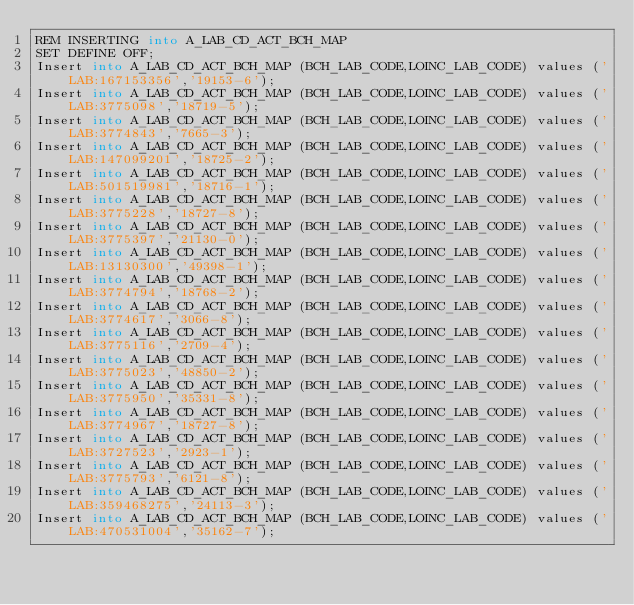Convert code to text. <code><loc_0><loc_0><loc_500><loc_500><_SQL_>REM INSERTING into A_LAB_CD_ACT_BCH_MAP
SET DEFINE OFF;
Insert into A_LAB_CD_ACT_BCH_MAP (BCH_LAB_CODE,LOINC_LAB_CODE) values ('LAB:167153356','19153-6');
Insert into A_LAB_CD_ACT_BCH_MAP (BCH_LAB_CODE,LOINC_LAB_CODE) values ('LAB:3775098','18719-5');
Insert into A_LAB_CD_ACT_BCH_MAP (BCH_LAB_CODE,LOINC_LAB_CODE) values ('LAB:3774843','7665-3');
Insert into A_LAB_CD_ACT_BCH_MAP (BCH_LAB_CODE,LOINC_LAB_CODE) values ('LAB:147099201','18725-2');
Insert into A_LAB_CD_ACT_BCH_MAP (BCH_LAB_CODE,LOINC_LAB_CODE) values ('LAB:501519981','18716-1');
Insert into A_LAB_CD_ACT_BCH_MAP (BCH_LAB_CODE,LOINC_LAB_CODE) values ('LAB:3775228','18727-8');
Insert into A_LAB_CD_ACT_BCH_MAP (BCH_LAB_CODE,LOINC_LAB_CODE) values ('LAB:3775397','21130-0');
Insert into A_LAB_CD_ACT_BCH_MAP (BCH_LAB_CODE,LOINC_LAB_CODE) values ('LAB:13130300','49398-1');
Insert into A_LAB_CD_ACT_BCH_MAP (BCH_LAB_CODE,LOINC_LAB_CODE) values ('LAB:3774794','18768-2');
Insert into A_LAB_CD_ACT_BCH_MAP (BCH_LAB_CODE,LOINC_LAB_CODE) values ('LAB:3774617','3066-8');
Insert into A_LAB_CD_ACT_BCH_MAP (BCH_LAB_CODE,LOINC_LAB_CODE) values ('LAB:3775116','2709-4');
Insert into A_LAB_CD_ACT_BCH_MAP (BCH_LAB_CODE,LOINC_LAB_CODE) values ('LAB:3775023','48850-2');
Insert into A_LAB_CD_ACT_BCH_MAP (BCH_LAB_CODE,LOINC_LAB_CODE) values ('LAB:3775950','35331-8');
Insert into A_LAB_CD_ACT_BCH_MAP (BCH_LAB_CODE,LOINC_LAB_CODE) values ('LAB:3774967','18727-8');
Insert into A_LAB_CD_ACT_BCH_MAP (BCH_LAB_CODE,LOINC_LAB_CODE) values ('LAB:3727523','2923-1');
Insert into A_LAB_CD_ACT_BCH_MAP (BCH_LAB_CODE,LOINC_LAB_CODE) values ('LAB:3775793','6121-8');
Insert into A_LAB_CD_ACT_BCH_MAP (BCH_LAB_CODE,LOINC_LAB_CODE) values ('LAB:359468275','24113-3');
Insert into A_LAB_CD_ACT_BCH_MAP (BCH_LAB_CODE,LOINC_LAB_CODE) values ('LAB:470531004','35162-7');</code> 